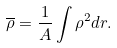<formula> <loc_0><loc_0><loc_500><loc_500>\overline { \rho } = \frac { 1 } { A } \int \rho ^ { 2 } d { r } .</formula> 